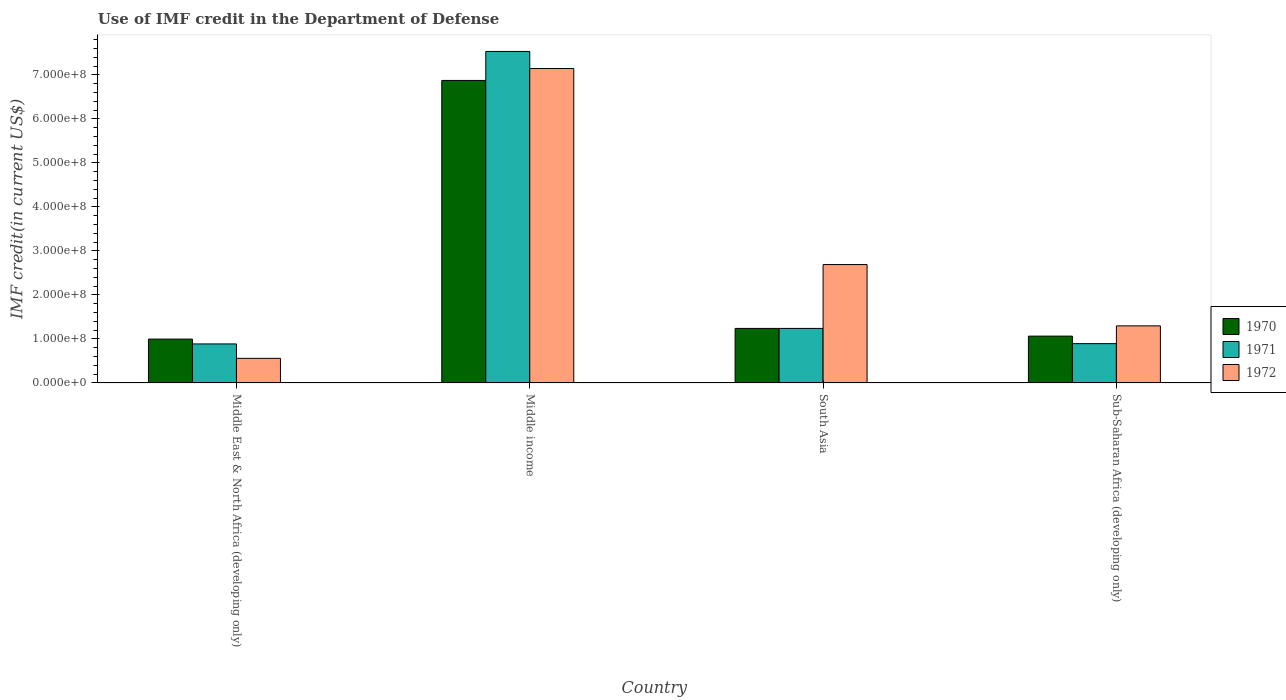Are the number of bars per tick equal to the number of legend labels?
Give a very brief answer. Yes. Are the number of bars on each tick of the X-axis equal?
Keep it short and to the point. Yes. How many bars are there on the 1st tick from the left?
Offer a terse response. 3. What is the label of the 4th group of bars from the left?
Your response must be concise. Sub-Saharan Africa (developing only). What is the IMF credit in the Department of Defense in 1971 in South Asia?
Offer a very short reply. 1.24e+08. Across all countries, what is the maximum IMF credit in the Department of Defense in 1970?
Ensure brevity in your answer.  6.87e+08. Across all countries, what is the minimum IMF credit in the Department of Defense in 1972?
Your answer should be compact. 5.59e+07. In which country was the IMF credit in the Department of Defense in 1970 maximum?
Make the answer very short. Middle income. In which country was the IMF credit in the Department of Defense in 1972 minimum?
Offer a terse response. Middle East & North Africa (developing only). What is the total IMF credit in the Department of Defense in 1972 in the graph?
Your answer should be compact. 1.17e+09. What is the difference between the IMF credit in the Department of Defense in 1972 in Middle East & North Africa (developing only) and that in South Asia?
Ensure brevity in your answer.  -2.13e+08. What is the difference between the IMF credit in the Department of Defense in 1971 in Middle East & North Africa (developing only) and the IMF credit in the Department of Defense in 1972 in South Asia?
Your response must be concise. -1.80e+08. What is the average IMF credit in the Department of Defense in 1970 per country?
Give a very brief answer. 2.54e+08. What is the difference between the IMF credit in the Department of Defense of/in 1972 and IMF credit in the Department of Defense of/in 1971 in Middle income?
Provide a succinct answer. -3.88e+07. What is the ratio of the IMF credit in the Department of Defense in 1970 in Middle East & North Africa (developing only) to that in Sub-Saharan Africa (developing only)?
Ensure brevity in your answer.  0.94. Is the IMF credit in the Department of Defense in 1971 in Middle East & North Africa (developing only) less than that in Sub-Saharan Africa (developing only)?
Give a very brief answer. Yes. Is the difference between the IMF credit in the Department of Defense in 1972 in South Asia and Sub-Saharan Africa (developing only) greater than the difference between the IMF credit in the Department of Defense in 1971 in South Asia and Sub-Saharan Africa (developing only)?
Keep it short and to the point. Yes. What is the difference between the highest and the second highest IMF credit in the Department of Defense in 1972?
Provide a short and direct response. -4.45e+08. What is the difference between the highest and the lowest IMF credit in the Department of Defense in 1971?
Offer a very short reply. 6.65e+08. Is the sum of the IMF credit in the Department of Defense in 1972 in Middle income and South Asia greater than the maximum IMF credit in the Department of Defense in 1971 across all countries?
Your answer should be very brief. Yes. What does the 3rd bar from the left in South Asia represents?
Your response must be concise. 1972. What does the 2nd bar from the right in Sub-Saharan Africa (developing only) represents?
Make the answer very short. 1971. How many bars are there?
Offer a terse response. 12. Are all the bars in the graph horizontal?
Keep it short and to the point. No. Are the values on the major ticks of Y-axis written in scientific E-notation?
Provide a succinct answer. Yes. Where does the legend appear in the graph?
Make the answer very short. Center right. What is the title of the graph?
Offer a terse response. Use of IMF credit in the Department of Defense. Does "1963" appear as one of the legend labels in the graph?
Keep it short and to the point. No. What is the label or title of the X-axis?
Your response must be concise. Country. What is the label or title of the Y-axis?
Your answer should be compact. IMF credit(in current US$). What is the IMF credit(in current US$) of 1970 in Middle East & North Africa (developing only)?
Offer a terse response. 9.96e+07. What is the IMF credit(in current US$) in 1971 in Middle East & North Africa (developing only)?
Give a very brief answer. 8.86e+07. What is the IMF credit(in current US$) of 1972 in Middle East & North Africa (developing only)?
Keep it short and to the point. 5.59e+07. What is the IMF credit(in current US$) in 1970 in Middle income?
Your answer should be compact. 6.87e+08. What is the IMF credit(in current US$) of 1971 in Middle income?
Offer a very short reply. 7.53e+08. What is the IMF credit(in current US$) in 1972 in Middle income?
Give a very brief answer. 7.14e+08. What is the IMF credit(in current US$) in 1970 in South Asia?
Your answer should be compact. 1.24e+08. What is the IMF credit(in current US$) of 1971 in South Asia?
Your answer should be very brief. 1.24e+08. What is the IMF credit(in current US$) of 1972 in South Asia?
Your answer should be very brief. 2.69e+08. What is the IMF credit(in current US$) of 1970 in Sub-Saharan Africa (developing only)?
Your answer should be very brief. 1.06e+08. What is the IMF credit(in current US$) of 1971 in Sub-Saharan Africa (developing only)?
Provide a short and direct response. 8.93e+07. What is the IMF credit(in current US$) in 1972 in Sub-Saharan Africa (developing only)?
Provide a succinct answer. 1.30e+08. Across all countries, what is the maximum IMF credit(in current US$) in 1970?
Your response must be concise. 6.87e+08. Across all countries, what is the maximum IMF credit(in current US$) of 1971?
Provide a succinct answer. 7.53e+08. Across all countries, what is the maximum IMF credit(in current US$) of 1972?
Provide a short and direct response. 7.14e+08. Across all countries, what is the minimum IMF credit(in current US$) in 1970?
Provide a succinct answer. 9.96e+07. Across all countries, what is the minimum IMF credit(in current US$) of 1971?
Make the answer very short. 8.86e+07. Across all countries, what is the minimum IMF credit(in current US$) in 1972?
Ensure brevity in your answer.  5.59e+07. What is the total IMF credit(in current US$) in 1970 in the graph?
Your answer should be compact. 1.02e+09. What is the total IMF credit(in current US$) of 1971 in the graph?
Make the answer very short. 1.06e+09. What is the total IMF credit(in current US$) in 1972 in the graph?
Your response must be concise. 1.17e+09. What is the difference between the IMF credit(in current US$) in 1970 in Middle East & North Africa (developing only) and that in Middle income?
Your response must be concise. -5.88e+08. What is the difference between the IMF credit(in current US$) of 1971 in Middle East & North Africa (developing only) and that in Middle income?
Keep it short and to the point. -6.65e+08. What is the difference between the IMF credit(in current US$) in 1972 in Middle East & North Africa (developing only) and that in Middle income?
Keep it short and to the point. -6.59e+08. What is the difference between the IMF credit(in current US$) in 1970 in Middle East & North Africa (developing only) and that in South Asia?
Your answer should be compact. -2.43e+07. What is the difference between the IMF credit(in current US$) in 1971 in Middle East & North Africa (developing only) and that in South Asia?
Provide a short and direct response. -3.53e+07. What is the difference between the IMF credit(in current US$) in 1972 in Middle East & North Africa (developing only) and that in South Asia?
Keep it short and to the point. -2.13e+08. What is the difference between the IMF credit(in current US$) of 1970 in Middle East & North Africa (developing only) and that in Sub-Saharan Africa (developing only)?
Keep it short and to the point. -6.78e+06. What is the difference between the IMF credit(in current US$) of 1971 in Middle East & North Africa (developing only) and that in Sub-Saharan Africa (developing only)?
Your answer should be compact. -6.60e+05. What is the difference between the IMF credit(in current US$) in 1972 in Middle East & North Africa (developing only) and that in Sub-Saharan Africa (developing only)?
Offer a very short reply. -7.38e+07. What is the difference between the IMF credit(in current US$) in 1970 in Middle income and that in South Asia?
Provide a short and direct response. 5.64e+08. What is the difference between the IMF credit(in current US$) in 1971 in Middle income and that in South Asia?
Provide a succinct answer. 6.29e+08. What is the difference between the IMF credit(in current US$) of 1972 in Middle income and that in South Asia?
Your answer should be very brief. 4.45e+08. What is the difference between the IMF credit(in current US$) of 1970 in Middle income and that in Sub-Saharan Africa (developing only)?
Make the answer very short. 5.81e+08. What is the difference between the IMF credit(in current US$) of 1971 in Middle income and that in Sub-Saharan Africa (developing only)?
Provide a short and direct response. 6.64e+08. What is the difference between the IMF credit(in current US$) of 1972 in Middle income and that in Sub-Saharan Africa (developing only)?
Offer a terse response. 5.85e+08. What is the difference between the IMF credit(in current US$) in 1970 in South Asia and that in Sub-Saharan Africa (developing only)?
Make the answer very short. 1.75e+07. What is the difference between the IMF credit(in current US$) in 1971 in South Asia and that in Sub-Saharan Africa (developing only)?
Provide a succinct answer. 3.46e+07. What is the difference between the IMF credit(in current US$) in 1972 in South Asia and that in Sub-Saharan Africa (developing only)?
Provide a short and direct response. 1.39e+08. What is the difference between the IMF credit(in current US$) in 1970 in Middle East & North Africa (developing only) and the IMF credit(in current US$) in 1971 in Middle income?
Make the answer very short. -6.54e+08. What is the difference between the IMF credit(in current US$) in 1970 in Middle East & North Africa (developing only) and the IMF credit(in current US$) in 1972 in Middle income?
Make the answer very short. -6.15e+08. What is the difference between the IMF credit(in current US$) of 1971 in Middle East & North Africa (developing only) and the IMF credit(in current US$) of 1972 in Middle income?
Give a very brief answer. -6.26e+08. What is the difference between the IMF credit(in current US$) in 1970 in Middle East & North Africa (developing only) and the IMF credit(in current US$) in 1971 in South Asia?
Your response must be concise. -2.43e+07. What is the difference between the IMF credit(in current US$) of 1970 in Middle East & North Africa (developing only) and the IMF credit(in current US$) of 1972 in South Asia?
Ensure brevity in your answer.  -1.69e+08. What is the difference between the IMF credit(in current US$) in 1971 in Middle East & North Africa (developing only) and the IMF credit(in current US$) in 1972 in South Asia?
Your response must be concise. -1.80e+08. What is the difference between the IMF credit(in current US$) of 1970 in Middle East & North Africa (developing only) and the IMF credit(in current US$) of 1971 in Sub-Saharan Africa (developing only)?
Your answer should be compact. 1.03e+07. What is the difference between the IMF credit(in current US$) in 1970 in Middle East & North Africa (developing only) and the IMF credit(in current US$) in 1972 in Sub-Saharan Africa (developing only)?
Ensure brevity in your answer.  -3.01e+07. What is the difference between the IMF credit(in current US$) of 1971 in Middle East & North Africa (developing only) and the IMF credit(in current US$) of 1972 in Sub-Saharan Africa (developing only)?
Give a very brief answer. -4.11e+07. What is the difference between the IMF credit(in current US$) in 1970 in Middle income and the IMF credit(in current US$) in 1971 in South Asia?
Provide a succinct answer. 5.64e+08. What is the difference between the IMF credit(in current US$) in 1970 in Middle income and the IMF credit(in current US$) in 1972 in South Asia?
Your answer should be very brief. 4.18e+08. What is the difference between the IMF credit(in current US$) in 1971 in Middle income and the IMF credit(in current US$) in 1972 in South Asia?
Give a very brief answer. 4.84e+08. What is the difference between the IMF credit(in current US$) in 1970 in Middle income and the IMF credit(in current US$) in 1971 in Sub-Saharan Africa (developing only)?
Provide a short and direct response. 5.98e+08. What is the difference between the IMF credit(in current US$) of 1970 in Middle income and the IMF credit(in current US$) of 1972 in Sub-Saharan Africa (developing only)?
Provide a short and direct response. 5.58e+08. What is the difference between the IMF credit(in current US$) in 1971 in Middle income and the IMF credit(in current US$) in 1972 in Sub-Saharan Africa (developing only)?
Provide a short and direct response. 6.24e+08. What is the difference between the IMF credit(in current US$) of 1970 in South Asia and the IMF credit(in current US$) of 1971 in Sub-Saharan Africa (developing only)?
Your answer should be very brief. 3.46e+07. What is the difference between the IMF credit(in current US$) of 1970 in South Asia and the IMF credit(in current US$) of 1972 in Sub-Saharan Africa (developing only)?
Make the answer very short. -5.79e+06. What is the difference between the IMF credit(in current US$) in 1971 in South Asia and the IMF credit(in current US$) in 1972 in Sub-Saharan Africa (developing only)?
Keep it short and to the point. -5.79e+06. What is the average IMF credit(in current US$) of 1970 per country?
Give a very brief answer. 2.54e+08. What is the average IMF credit(in current US$) of 1971 per country?
Your response must be concise. 2.64e+08. What is the average IMF credit(in current US$) in 1972 per country?
Keep it short and to the point. 2.92e+08. What is the difference between the IMF credit(in current US$) of 1970 and IMF credit(in current US$) of 1971 in Middle East & North Africa (developing only)?
Give a very brief answer. 1.10e+07. What is the difference between the IMF credit(in current US$) in 1970 and IMF credit(in current US$) in 1972 in Middle East & North Africa (developing only)?
Make the answer very short. 4.37e+07. What is the difference between the IMF credit(in current US$) in 1971 and IMF credit(in current US$) in 1972 in Middle East & North Africa (developing only)?
Provide a succinct answer. 3.27e+07. What is the difference between the IMF credit(in current US$) in 1970 and IMF credit(in current US$) in 1971 in Middle income?
Keep it short and to the point. -6.58e+07. What is the difference between the IMF credit(in current US$) of 1970 and IMF credit(in current US$) of 1972 in Middle income?
Make the answer very short. -2.71e+07. What is the difference between the IMF credit(in current US$) in 1971 and IMF credit(in current US$) in 1972 in Middle income?
Offer a terse response. 3.88e+07. What is the difference between the IMF credit(in current US$) of 1970 and IMF credit(in current US$) of 1972 in South Asia?
Your answer should be very brief. -1.45e+08. What is the difference between the IMF credit(in current US$) in 1971 and IMF credit(in current US$) in 1972 in South Asia?
Provide a succinct answer. -1.45e+08. What is the difference between the IMF credit(in current US$) of 1970 and IMF credit(in current US$) of 1971 in Sub-Saharan Africa (developing only)?
Provide a succinct answer. 1.71e+07. What is the difference between the IMF credit(in current US$) of 1970 and IMF credit(in current US$) of 1972 in Sub-Saharan Africa (developing only)?
Offer a very short reply. -2.33e+07. What is the difference between the IMF credit(in current US$) of 1971 and IMF credit(in current US$) of 1972 in Sub-Saharan Africa (developing only)?
Make the answer very short. -4.04e+07. What is the ratio of the IMF credit(in current US$) of 1970 in Middle East & North Africa (developing only) to that in Middle income?
Offer a terse response. 0.14. What is the ratio of the IMF credit(in current US$) in 1971 in Middle East & North Africa (developing only) to that in Middle income?
Offer a very short reply. 0.12. What is the ratio of the IMF credit(in current US$) of 1972 in Middle East & North Africa (developing only) to that in Middle income?
Your response must be concise. 0.08. What is the ratio of the IMF credit(in current US$) in 1970 in Middle East & North Africa (developing only) to that in South Asia?
Your answer should be compact. 0.8. What is the ratio of the IMF credit(in current US$) in 1971 in Middle East & North Africa (developing only) to that in South Asia?
Your response must be concise. 0.72. What is the ratio of the IMF credit(in current US$) in 1972 in Middle East & North Africa (developing only) to that in South Asia?
Keep it short and to the point. 0.21. What is the ratio of the IMF credit(in current US$) of 1970 in Middle East & North Africa (developing only) to that in Sub-Saharan Africa (developing only)?
Ensure brevity in your answer.  0.94. What is the ratio of the IMF credit(in current US$) of 1972 in Middle East & North Africa (developing only) to that in Sub-Saharan Africa (developing only)?
Make the answer very short. 0.43. What is the ratio of the IMF credit(in current US$) of 1970 in Middle income to that in South Asia?
Provide a short and direct response. 5.55. What is the ratio of the IMF credit(in current US$) in 1971 in Middle income to that in South Asia?
Provide a short and direct response. 6.08. What is the ratio of the IMF credit(in current US$) of 1972 in Middle income to that in South Asia?
Offer a terse response. 2.66. What is the ratio of the IMF credit(in current US$) in 1970 in Middle income to that in Sub-Saharan Africa (developing only)?
Provide a succinct answer. 6.46. What is the ratio of the IMF credit(in current US$) in 1971 in Middle income to that in Sub-Saharan Africa (developing only)?
Ensure brevity in your answer.  8.44. What is the ratio of the IMF credit(in current US$) of 1972 in Middle income to that in Sub-Saharan Africa (developing only)?
Your answer should be compact. 5.51. What is the ratio of the IMF credit(in current US$) in 1970 in South Asia to that in Sub-Saharan Africa (developing only)?
Provide a short and direct response. 1.16. What is the ratio of the IMF credit(in current US$) of 1971 in South Asia to that in Sub-Saharan Africa (developing only)?
Provide a succinct answer. 1.39. What is the ratio of the IMF credit(in current US$) in 1972 in South Asia to that in Sub-Saharan Africa (developing only)?
Ensure brevity in your answer.  2.07. What is the difference between the highest and the second highest IMF credit(in current US$) in 1970?
Your answer should be compact. 5.64e+08. What is the difference between the highest and the second highest IMF credit(in current US$) in 1971?
Your response must be concise. 6.29e+08. What is the difference between the highest and the second highest IMF credit(in current US$) in 1972?
Ensure brevity in your answer.  4.45e+08. What is the difference between the highest and the lowest IMF credit(in current US$) of 1970?
Your response must be concise. 5.88e+08. What is the difference between the highest and the lowest IMF credit(in current US$) in 1971?
Keep it short and to the point. 6.65e+08. What is the difference between the highest and the lowest IMF credit(in current US$) in 1972?
Keep it short and to the point. 6.59e+08. 